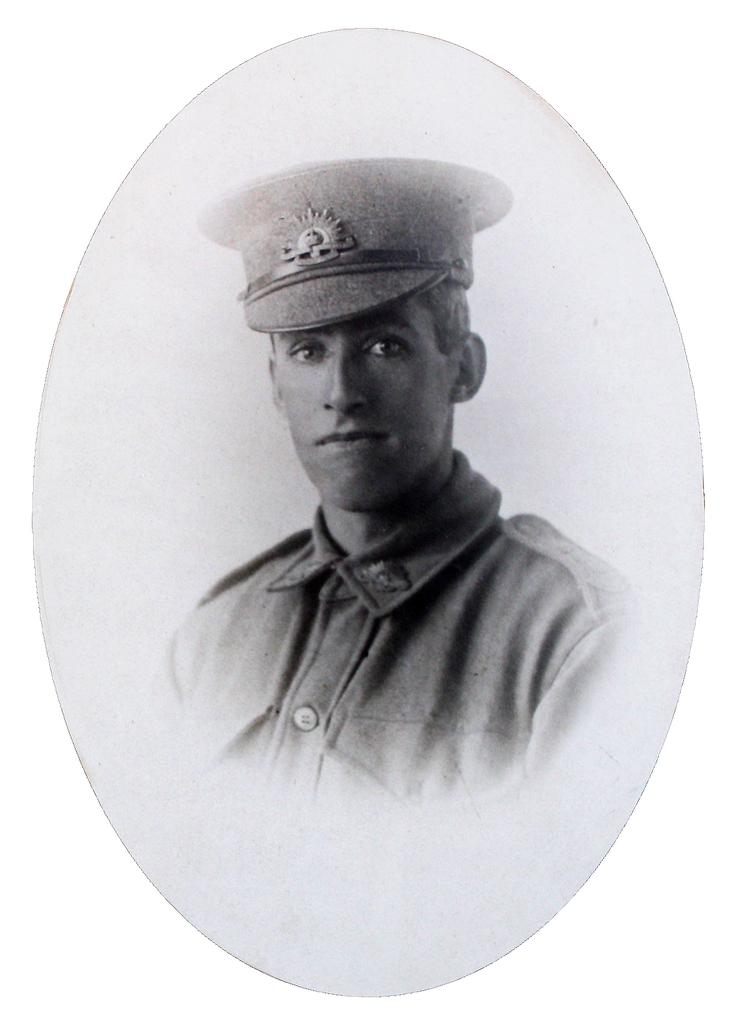What is the main subject of the image? There is a photo of a man in the image. What color is the background of the image? The background of the image is white. Where is the market located in the image? There is no market present in the image; it only features a photo of a man with a white background. 